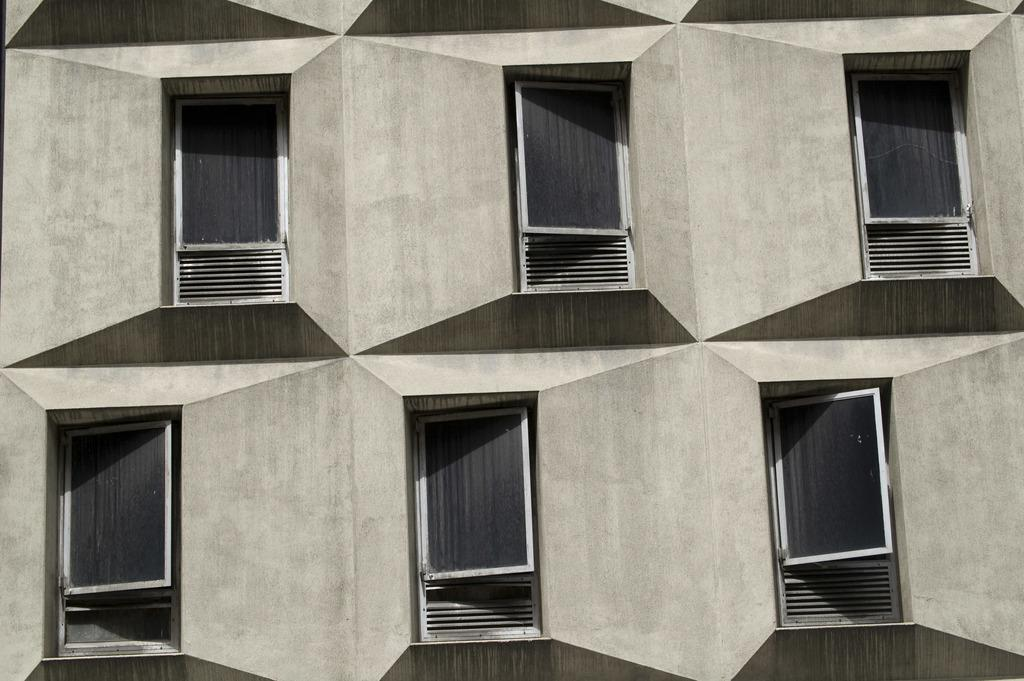How many windows are visible in the building? There are many windows in the building. Can you tell me how many snails are crawling on the windows of the building? There is no information about snails in the image, so it is not possible to answer that question. 